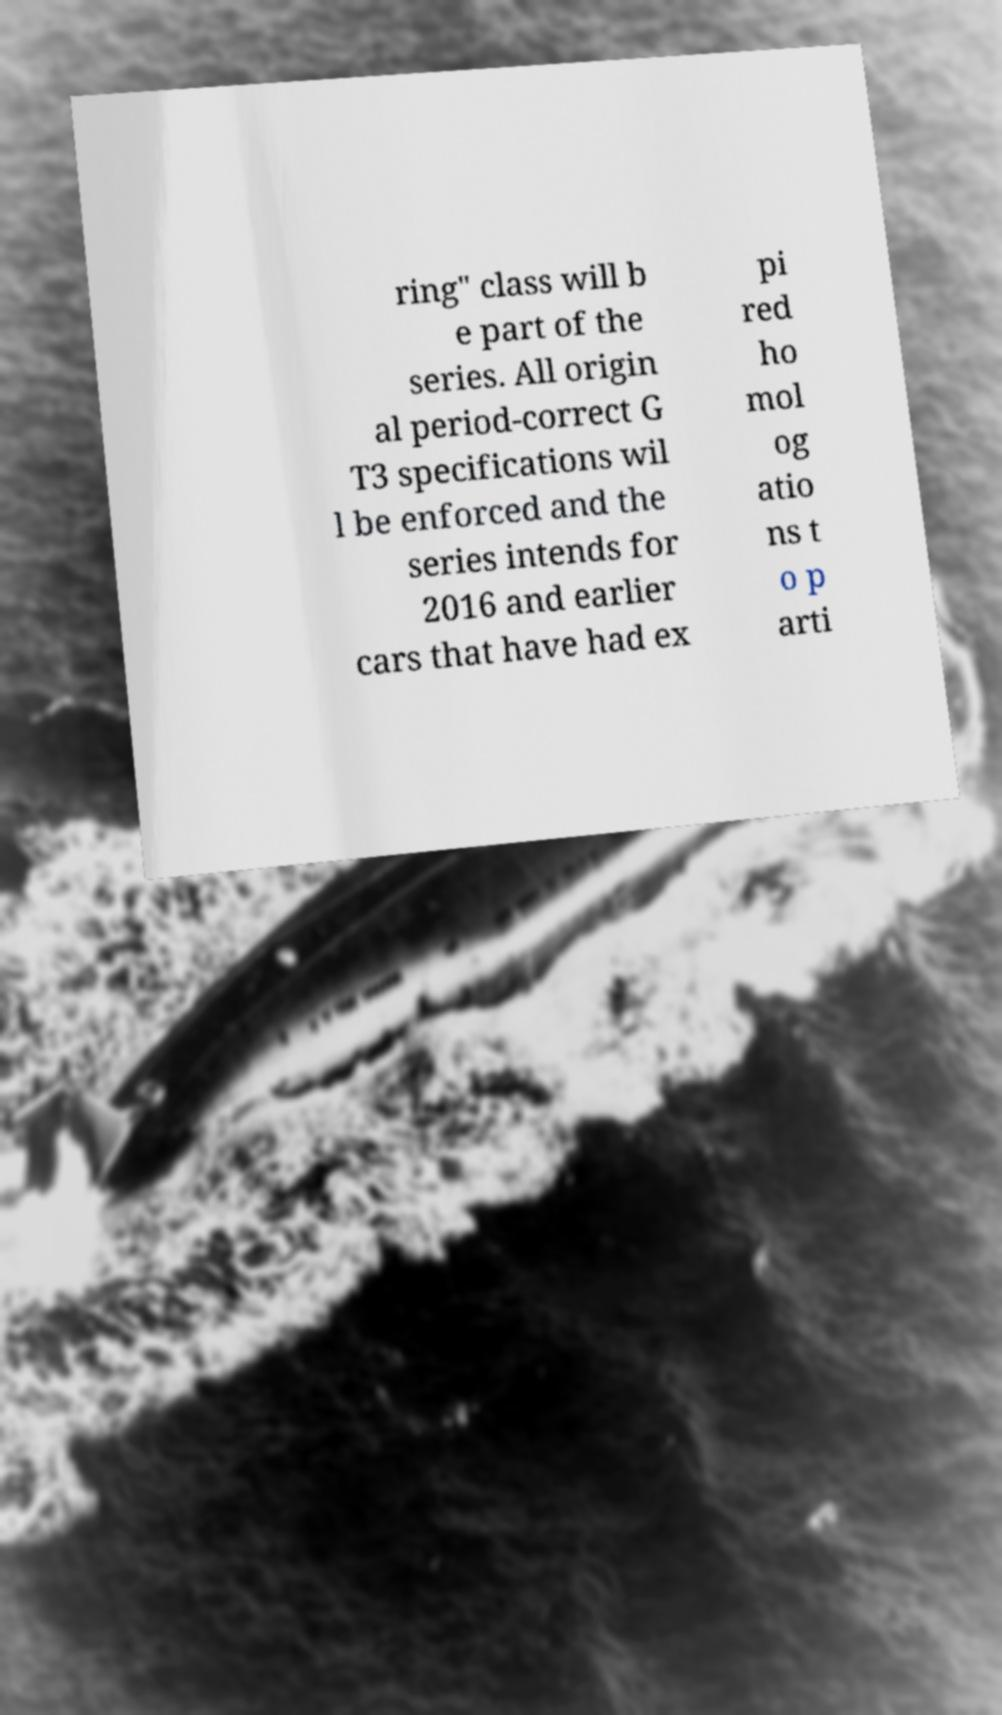I need the written content from this picture converted into text. Can you do that? ring" class will b e part of the series. All origin al period-correct G T3 specifications wil l be enforced and the series intends for 2016 and earlier cars that have had ex pi red ho mol og atio ns t o p arti 